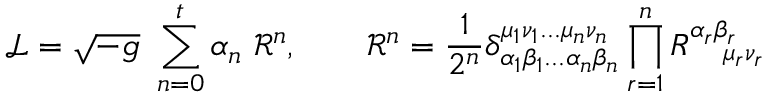Convert formula to latex. <formula><loc_0><loc_0><loc_500><loc_500>{ \mathcal { L } } = { \sqrt { - g } } \ \sum _ { n = 0 } ^ { t } \alpha _ { n } \ { \mathcal { R } } ^ { n } , \quad { \mathcal { R } } ^ { n } = { \frac { 1 } { 2 ^ { n } } } \delta _ { \alpha _ { 1 } \beta _ { 1 } \dots \alpha _ { n } \beta _ { n } } ^ { \mu _ { 1 } \nu _ { 1 } \dots \mu _ { n } \nu _ { n } } \prod _ { r = 1 } ^ { n } R _ { \quad \mu _ { r } \nu _ { r } } ^ { \alpha _ { r } \beta _ { r } }</formula> 